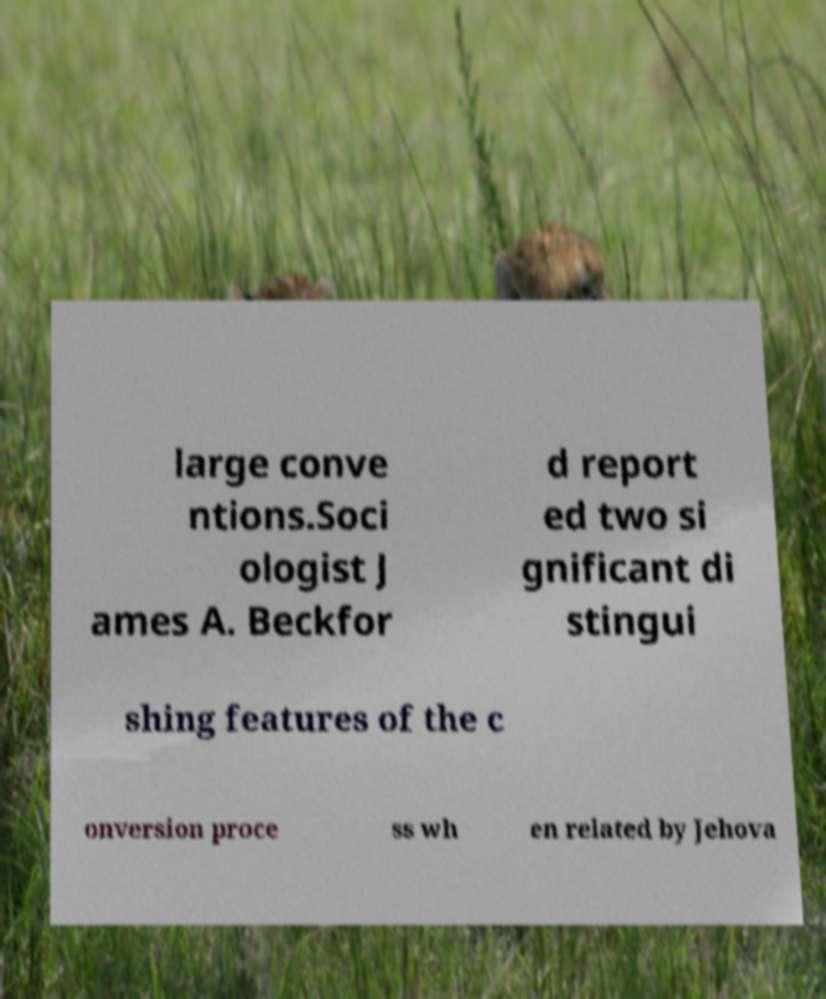There's text embedded in this image that I need extracted. Can you transcribe it verbatim? large conve ntions.Soci ologist J ames A. Beckfor d report ed two si gnificant di stingui shing features of the c onversion proce ss wh en related by Jehova 